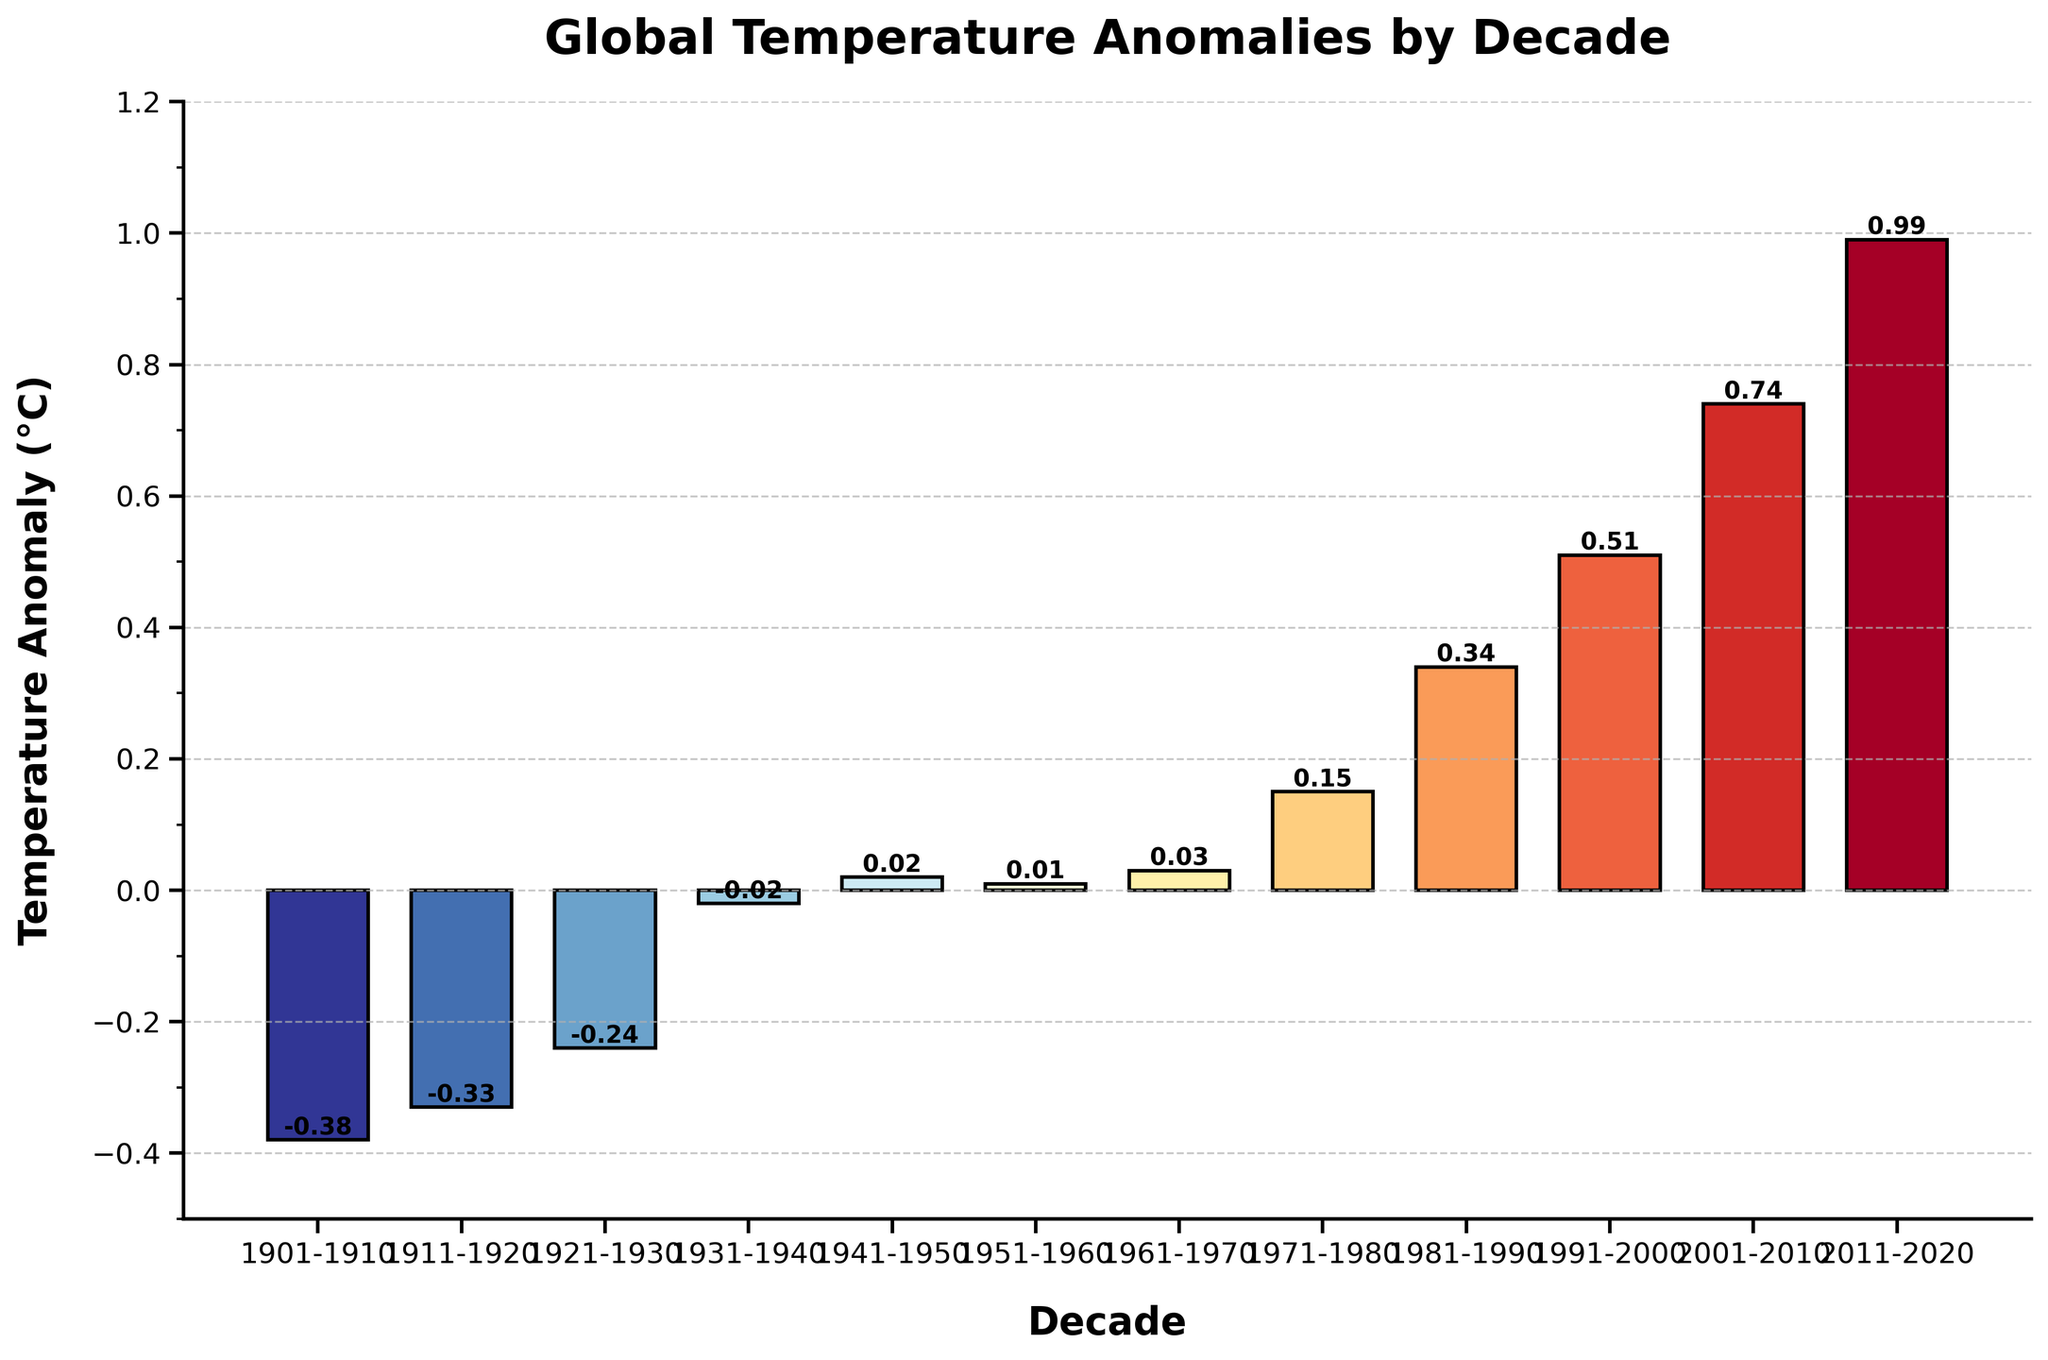What is the temperature anomaly in the decade 1931-1940? Look at the bar corresponding to the decade 1931-1940 and check the height or the value label on the bar.
Answer: -0.02 Which decade had the highest temperature anomaly? Compare the height of all the bars or the value labels on the bars to determine the highest one.
Answer: 2011-2020 What is the difference in temperature anomalies between the decade 2011-2020 and 1991-2000? Find the temperature anomalies for the decades 2011-2020 and 1991-2000 (0.99 and 0.51 respectively), then subtract the latter from the former: 0.99 - 0.51.
Answer: 0.48 Which decade had a negative temperature anomaly closest to zero? Identify the bars with negative values and determine the one closest to zero by comparing their heights or value labels.
Answer: 1931-1940 Which decade shows the first instance of a positive temperature anomaly? Look for the first decade with a bar height above zero or a positive value label.
Answer: 1941-1950 What is the average temperature anomaly over the period 1981-2020? Sum the anomalies for 1981-1990 (0.34), 1991-2000 (0.51), 2001-2010 (0.74), and 2011-2020 (0.99). Divide the sum by the number of decades: (0.34 + 0.51 + 0.74 + 0.99) / 4.
Answer: 0.645 How much did the temperature anomaly increase from the first decade (1901-1910) to the last decade (2011-2020)? Subtract the anomaly of 1901-1910 (-0.38) from the anomaly of 2011-2020 (0.99): 0.99 - (-0.38).
Answer: 1.37 Which decade had a temperature anomaly of 0.15°C? Identify the bar with a height or value label of 0.15.
Answer: 1971-1980 